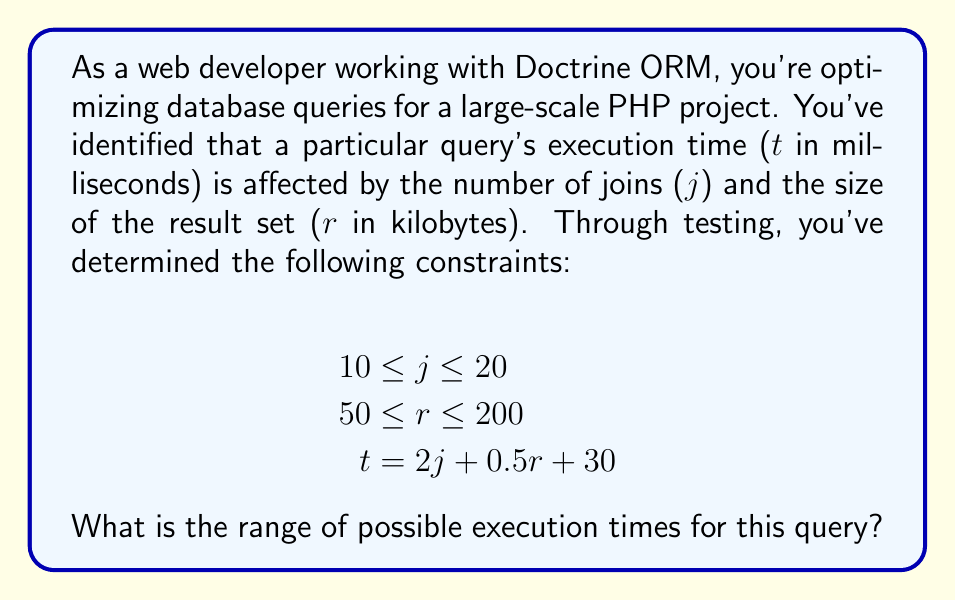Solve this math problem. To find the range of possible execution times, we need to determine the minimum and maximum values of $t$ given the constraints on $j$ and $r$.

1. Minimum execution time:
   - Use the minimum values for $j$ and $r$
   - $j_{min} = 10$ and $r_{min} = 50$
   - $t_{min} = 2(10) + 0.5(50) + 30$
   - $t_{min} = 20 + 25 + 30 = 75$ ms

2. Maximum execution time:
   - Use the maximum values for $j$ and $r$
   - $j_{max} = 20$ and $r_{max} = 200$
   - $t_{max} = 2(20) + 0.5(200) + 30$
   - $t_{max} = 40 + 100 + 30 = 170$ ms

Therefore, the range of possible execution times is from 75 ms to 170 ms.

To express this as an inequality:

$$75 \leq t \leq 170$$

This result is particularly relevant for a web developer working with Doctrine ORM, as it provides insights into query performance boundaries, which can be used for optimization and setting performance expectations in the PHP project.
Answer: The range of possible execution times is $75 \leq t \leq 170$ milliseconds. 